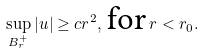<formula> <loc_0><loc_0><loc_500><loc_500>\sup _ { B _ { r } ^ { + } } | u | \geq c r ^ { 2 } , \, \text {for} \, r < r _ { 0 } .</formula> 